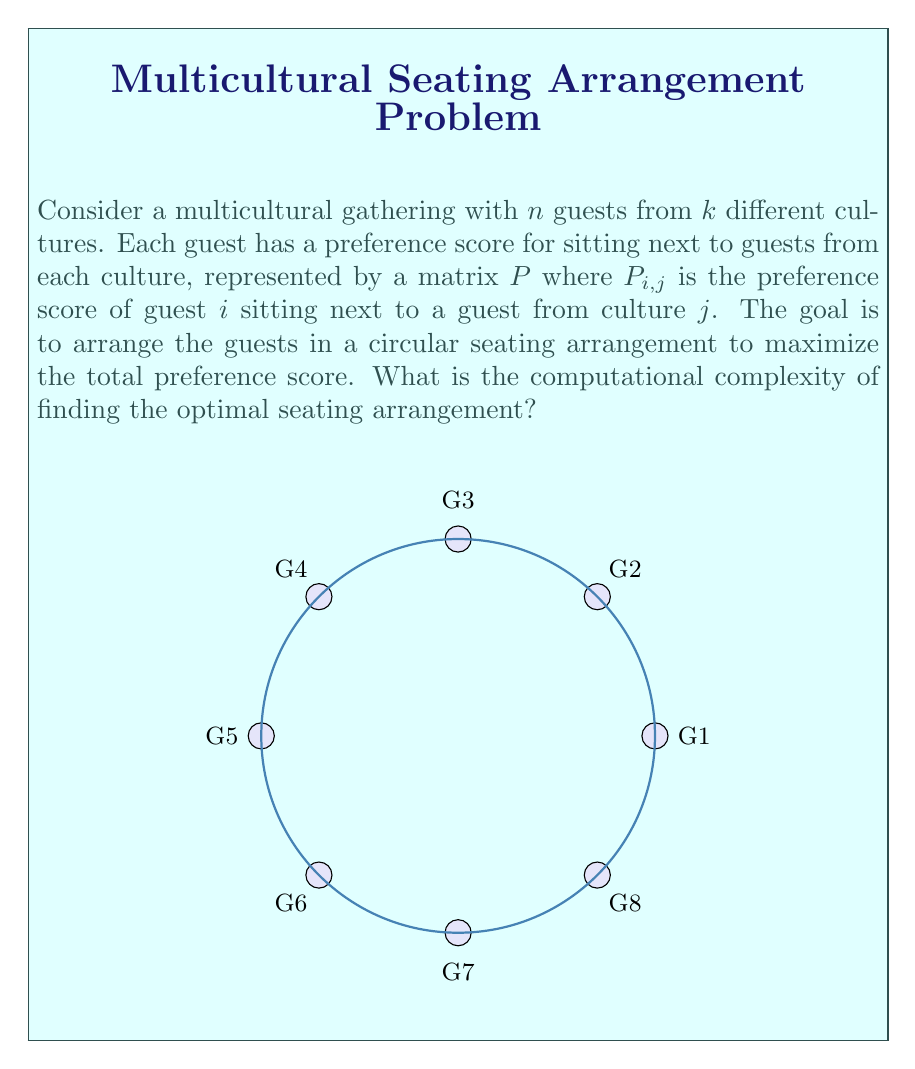Give your solution to this math problem. To determine the computational complexity of this problem, we need to analyze it step by step:

1) First, we recognize that this problem is a variation of the Traveling Salesman Problem (TSP), where instead of minimizing distances, we're maximizing preference scores.

2) The key difference is that we're dealing with a circular arrangement, which means we can fix the position of one guest and permute the rest.

3) For $n$ guests, we have $(n-1)!$ possible permutations.

4) For each permutation, we need to calculate the total preference score:
   - This involves summing $n$ preference scores (each guest's preference for their two neighbors)
   - Each score lookup takes $O(1)$ time
   - So, calculating the score for one permutation takes $O(n)$ time

5) Therefore, the total time to check all permutations is $O(n! \cdot n)$

6) This is a brute-force approach, and there's no known polynomial-time algorithm to solve this problem optimally for all inputs.

7) The decision version of this problem ("Is there a seating arrangement with a total preference score of at least $K$?") is NP-complete, as it's a variation of the TSP, which is a known NP-complete problem.

8) The optimization version (finding the actual optimal arrangement) is at least as hard as the decision version, so it's NP-hard.

Given these considerations, we can conclude that the problem is NP-hard, and the best known exact algorithms have exponential time complexity.
Answer: NP-hard, $O(n! \cdot n)$ for exact solution 